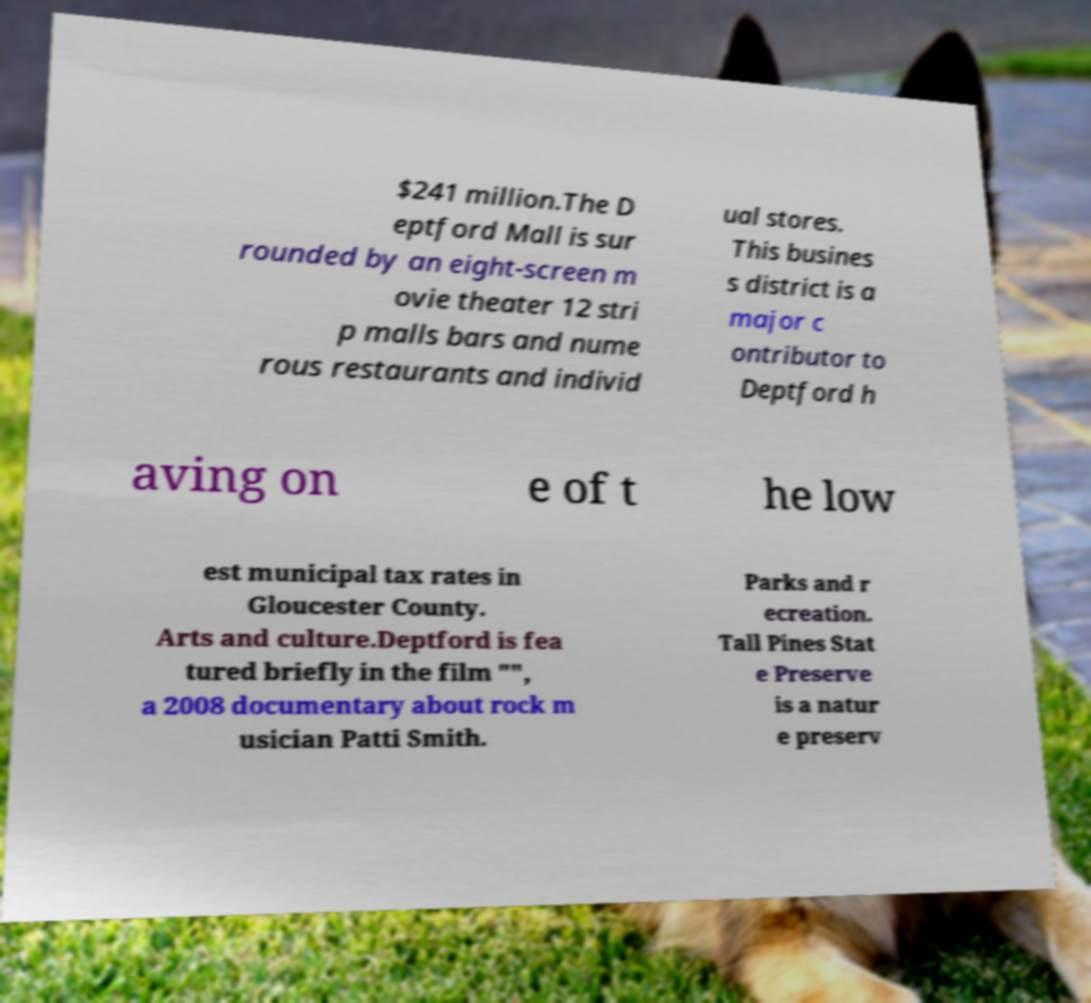Can you accurately transcribe the text from the provided image for me? $241 million.The D eptford Mall is sur rounded by an eight-screen m ovie theater 12 stri p malls bars and nume rous restaurants and individ ual stores. This busines s district is a major c ontributor to Deptford h aving on e of t he low est municipal tax rates in Gloucester County. Arts and culture.Deptford is fea tured briefly in the film "", a 2008 documentary about rock m usician Patti Smith. Parks and r ecreation. Tall Pines Stat e Preserve is a natur e preserv 